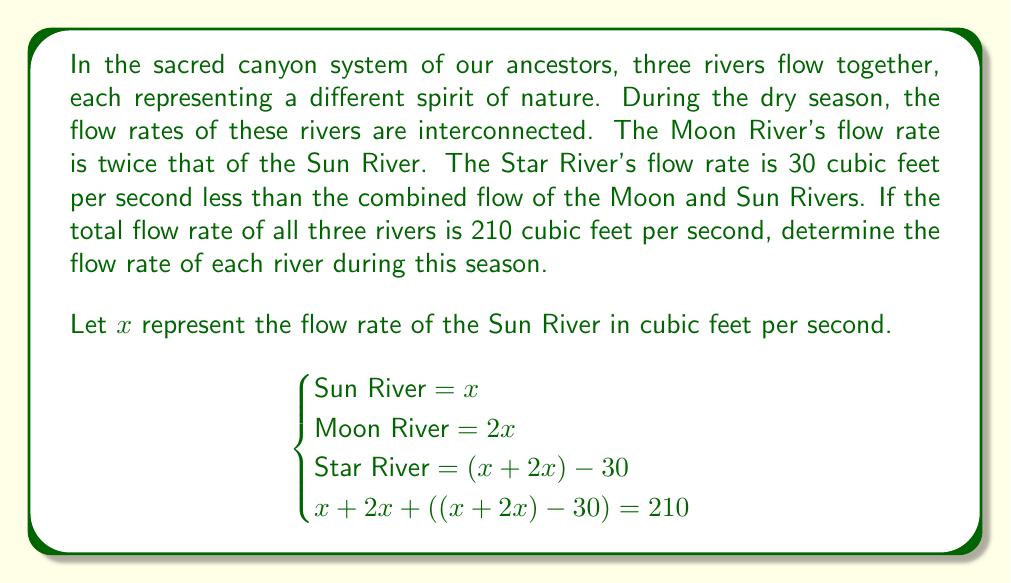Provide a solution to this math problem. To solve this system of equations, we'll follow these steps:

1) First, let's simplify the equation for the Star River:
   Star River $= (x + 2x) - 30 = 3x - 30$

2) Now, we can substitute this into our total flow equation:
   $x + 2x + (3x - 30) = 210$

3) Simplify the left side of the equation:
   $x + 2x + 3x - 30 = 210$
   $6x - 30 = 210$

4) Add 30 to both sides:
   $6x = 240$

5) Divide both sides by 6:
   $x = 40$

6) Now that we know $x$, we can calculate the flow rates for each river:

   Sun River $= x = 40$ cubic feet per second
   Moon River $= 2x = 2(40) = 80$ cubic feet per second
   Star River $= 3x - 30 = 3(40) - 30 = 90$ cubic feet per second

7) To verify, let's check if the total flow rate equals 210:
   $40 + 80 + 90 = 210$ cubic feet per second

Thus, our solution satisfies the given conditions.
Answer: Sun River: 40 cubic feet per second
Moon River: 80 cubic feet per second
Star River: 90 cubic feet per second 